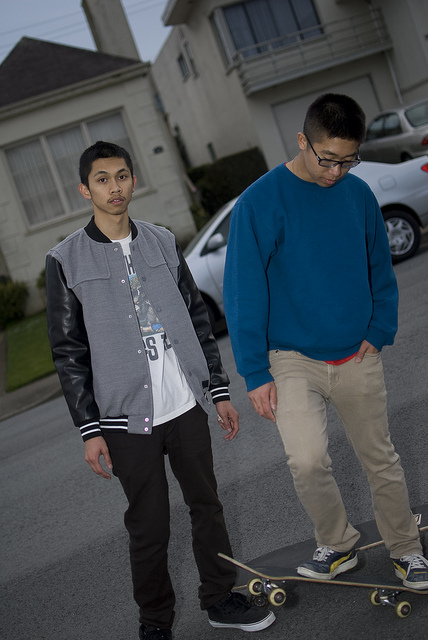Can you tell me about the fashion style of the individuals? Certainly! The individual on the left is sporting a contemporary urban style with a varsity jacket, jeans, and sneakers, exuding a relaxed streetwear vibe. The individual on the right opts for a more minimalist look with a plain blue sweater, khaki pants, and simple glasses, emphasizing a smart-casual aesthetic. 